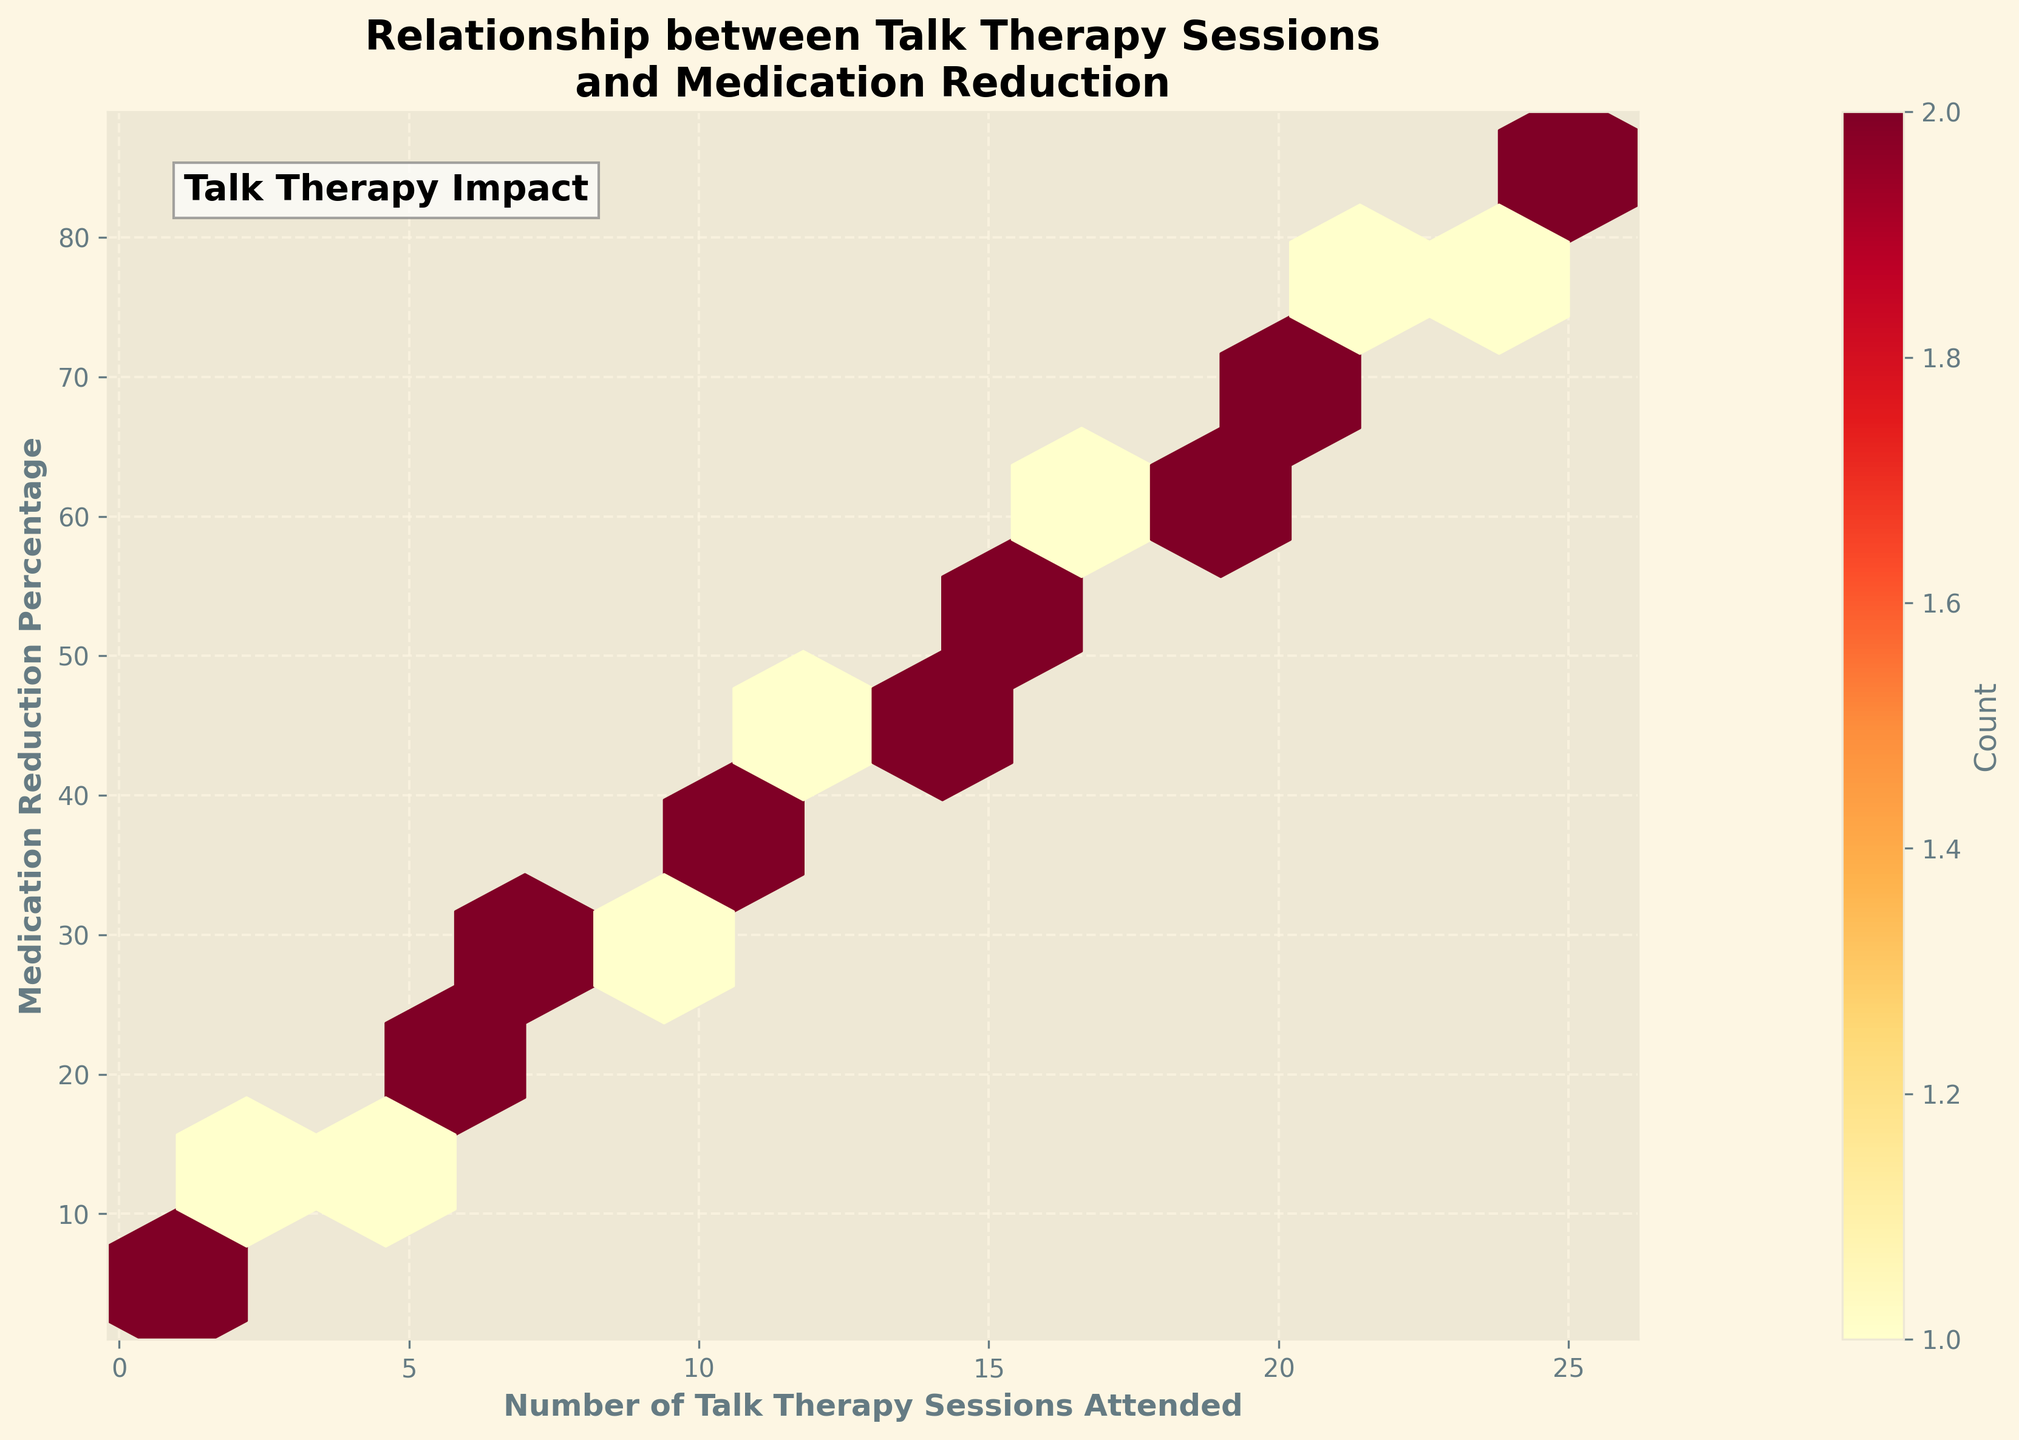How many bins are there in the Hexbin Plot? The Hexbin Plot is created with a gridsize of 10, meaning that there are 10 bins along both x and y axes. This results in a grid of 10x10 bins.
Answer: 100 What color is most commonly seen in the plot? The color map used in the plot is 'YlOrRd', which ranges from yellow to red to indicate increasing data point density. The most common color appears to be in the red shades, suggesting higher density in those regions.
Answer: Red What do the two axes represent? The x-axis is labeled 'Number of Talk Therapy Sessions Attended', and the y-axis is labeled 'Medication Reduction Percentage'.
Answer: Number of Talk Therapy Sessions and Medication Reduction Percentage Is there a general trend visible in the plot? The hexbin plot shows a diagonal trend from bottom-left to top-right, indicating that as the number of talk therapy sessions attended increases, the percentage reduction in medication also tends to increase.
Answer: Yes, positive trend What is the approximate medication reduction percentage for 10 talk therapy sessions attended? By looking at the plot, you can see that for 10 sessions, the corresponding medication reduction percentage is marked around the 35% region.
Answer: 35% Which sessions attended shows the highest density of medication reduction? The area around 'Number of Talk Therapy Sessions Attended' 10-15 and 'Medication Reduction Percentage' 35-52 has the highest density, indicated by the red color.
Answer: 10-15 sessions What is the highest medication reduction percentage observed in the plot? The highest data point on the y-axis of the plot corresponds to 85%, which is the maximum reduction percentage observed.
Answer: 85% How does the density change as the number of sessions increases? As the number of sessions increases, the density of data points (color intensity) tends to get higher initially and then spreads out more thinly beyond 20 sessions.
Answer: Higher initially then thinner Is the trend in medication reduction percentage linear? The plot shows a generally increasing trend in medication reduction percentage with the number of talk therapy sessions attended, suggesting a near-linear trend.
Answer: Near-linear trend 